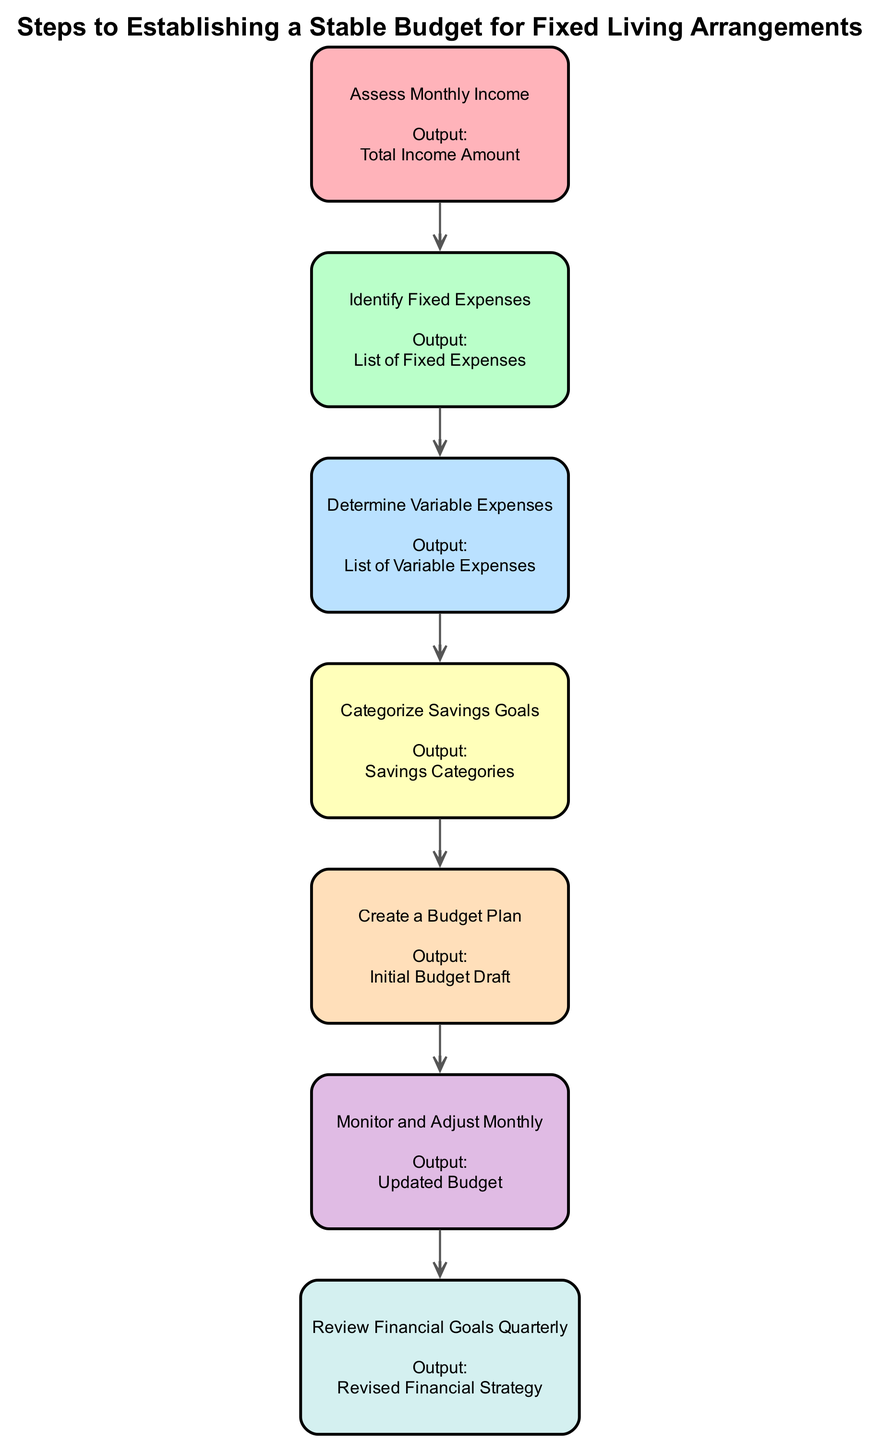What is the first step in establishing a stable budget? The first step is to assess monthly income, which allows the individual to recognize their total income amount before making any financial plans.
Answer: Assess Monthly Income How many total steps are there in the diagram? The diagram lists seven distinct steps that outline the process of establishing a stable budget.
Answer: Seven What is the output of the last step? The last step involves reviewing financial goals quarterly, which leads to the revised financial strategy as the output.
Answer: Revised Financial Strategy What step comes immediately after creating a budget plan? After creating the budget plan, the next step is to monitor and adjust the budget monthly, ensuring it remains relevant and effective.
Answer: Monitor and Adjust Monthly Which step involves identifying fixed expenses? The second step specifically focuses on identifying fixed expenses, ensuring that all regular, necessary costs are accounted for in the budget planning process.
Answer: Identify Fixed Expenses What is the relationship between the step of determining variable expenses and creating a budget plan? The step of determining variable expenses is crucial for creating a budget plan because it provides essential data on expenses that can fluctuate, allowing for a more accurate and realistic budget draft.
Answer: Causal Relationship What is the main purpose of categorizing savings goals? Categorizing savings goals helps to clearly define savings priorities, which ensures that financial planning can accommodate specific saving needs and objectives.
Answer: Define Savings Priorities How often should financial goals be reviewed according to the diagram? Financial goals should be reviewed quarterly as per the diagram, allowing for adjustments and recalibrations based on financial performance and changing circumstances.
Answer: Quarterly 